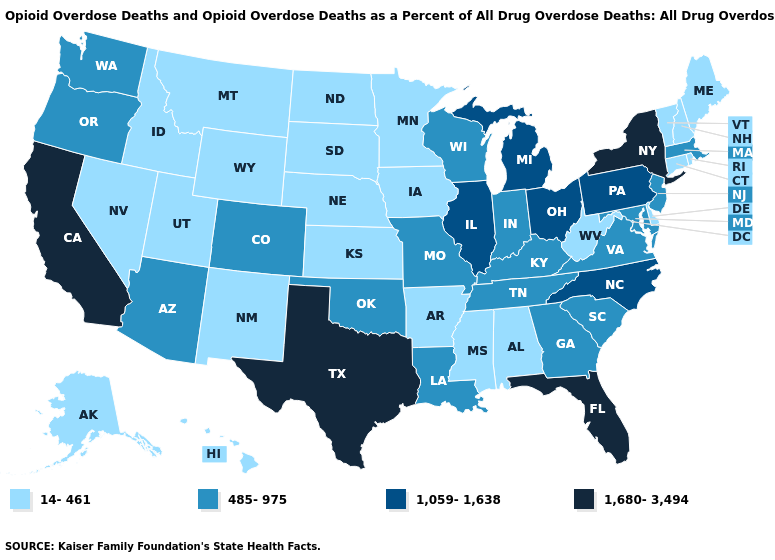What is the value of Ohio?
Keep it brief. 1,059-1,638. Which states have the lowest value in the USA?
Give a very brief answer. Alabama, Alaska, Arkansas, Connecticut, Delaware, Hawaii, Idaho, Iowa, Kansas, Maine, Minnesota, Mississippi, Montana, Nebraska, Nevada, New Hampshire, New Mexico, North Dakota, Rhode Island, South Dakota, Utah, Vermont, West Virginia, Wyoming. Among the states that border New Jersey , does New York have the highest value?
Write a very short answer. Yes. Among the states that border Rhode Island , does Connecticut have the highest value?
Write a very short answer. No. Does Rhode Island have a lower value than New York?
Give a very brief answer. Yes. Name the states that have a value in the range 1,680-3,494?
Keep it brief. California, Florida, New York, Texas. What is the value of Alabama?
Write a very short answer. 14-461. Among the states that border Georgia , does Tennessee have the lowest value?
Write a very short answer. No. Does Tennessee have the lowest value in the USA?
Answer briefly. No. What is the lowest value in the West?
Concise answer only. 14-461. Among the states that border Nebraska , which have the lowest value?
Answer briefly. Iowa, Kansas, South Dakota, Wyoming. What is the value of Illinois?
Short answer required. 1,059-1,638. Among the states that border Idaho , does Washington have the highest value?
Quick response, please. Yes. Which states have the highest value in the USA?
Answer briefly. California, Florida, New York, Texas. Does Colorado have the same value as Hawaii?
Keep it brief. No. 